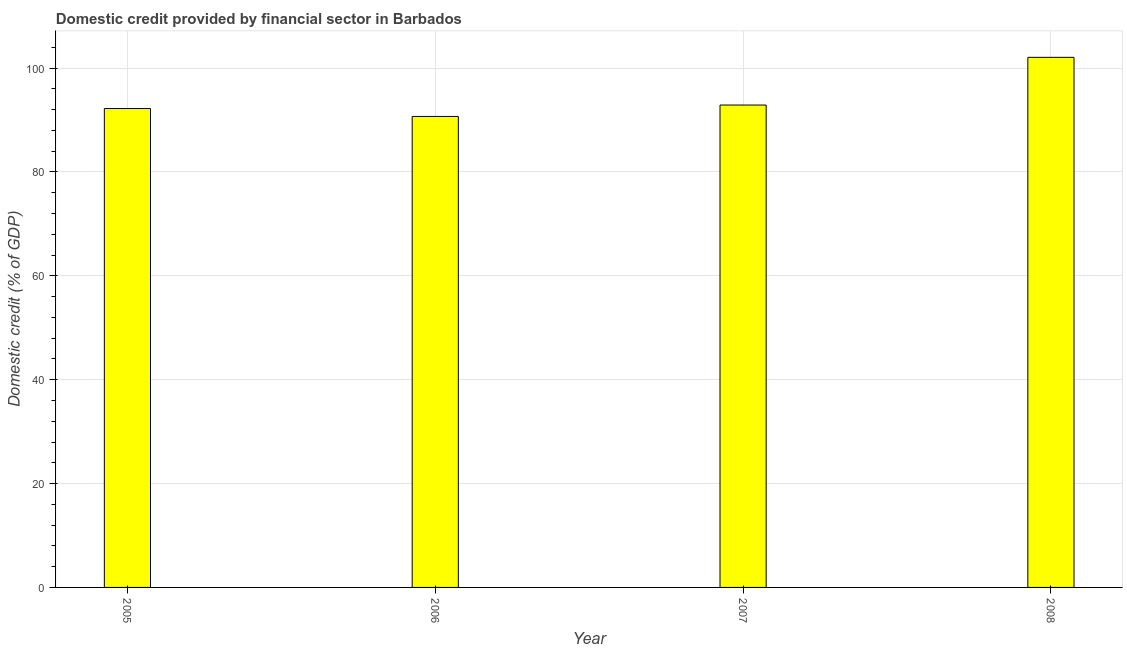Does the graph contain grids?
Provide a short and direct response. Yes. What is the title of the graph?
Offer a very short reply. Domestic credit provided by financial sector in Barbados. What is the label or title of the X-axis?
Your answer should be very brief. Year. What is the label or title of the Y-axis?
Keep it short and to the point. Domestic credit (% of GDP). What is the domestic credit provided by financial sector in 2007?
Give a very brief answer. 92.89. Across all years, what is the maximum domestic credit provided by financial sector?
Provide a short and direct response. 102.07. Across all years, what is the minimum domestic credit provided by financial sector?
Your answer should be very brief. 90.69. In which year was the domestic credit provided by financial sector minimum?
Offer a terse response. 2006. What is the sum of the domestic credit provided by financial sector?
Provide a short and direct response. 377.86. What is the difference between the domestic credit provided by financial sector in 2005 and 2008?
Offer a terse response. -9.86. What is the average domestic credit provided by financial sector per year?
Your answer should be very brief. 94.47. What is the median domestic credit provided by financial sector?
Your answer should be compact. 92.55. In how many years, is the domestic credit provided by financial sector greater than 48 %?
Provide a succinct answer. 4. What is the ratio of the domestic credit provided by financial sector in 2007 to that in 2008?
Keep it short and to the point. 0.91. What is the difference between the highest and the second highest domestic credit provided by financial sector?
Keep it short and to the point. 9.19. Is the sum of the domestic credit provided by financial sector in 2006 and 2008 greater than the maximum domestic credit provided by financial sector across all years?
Offer a very short reply. Yes. What is the difference between the highest and the lowest domestic credit provided by financial sector?
Offer a very short reply. 11.38. Are all the bars in the graph horizontal?
Ensure brevity in your answer.  No. What is the difference between two consecutive major ticks on the Y-axis?
Provide a short and direct response. 20. Are the values on the major ticks of Y-axis written in scientific E-notation?
Provide a short and direct response. No. What is the Domestic credit (% of GDP) in 2005?
Offer a very short reply. 92.21. What is the Domestic credit (% of GDP) in 2006?
Make the answer very short. 90.69. What is the Domestic credit (% of GDP) in 2007?
Offer a very short reply. 92.89. What is the Domestic credit (% of GDP) of 2008?
Offer a very short reply. 102.07. What is the difference between the Domestic credit (% of GDP) in 2005 and 2006?
Provide a succinct answer. 1.52. What is the difference between the Domestic credit (% of GDP) in 2005 and 2007?
Your response must be concise. -0.68. What is the difference between the Domestic credit (% of GDP) in 2005 and 2008?
Your response must be concise. -9.86. What is the difference between the Domestic credit (% of GDP) in 2006 and 2007?
Provide a succinct answer. -2.2. What is the difference between the Domestic credit (% of GDP) in 2006 and 2008?
Your response must be concise. -11.38. What is the difference between the Domestic credit (% of GDP) in 2007 and 2008?
Offer a very short reply. -9.19. What is the ratio of the Domestic credit (% of GDP) in 2005 to that in 2008?
Ensure brevity in your answer.  0.9. What is the ratio of the Domestic credit (% of GDP) in 2006 to that in 2007?
Ensure brevity in your answer.  0.98. What is the ratio of the Domestic credit (% of GDP) in 2006 to that in 2008?
Your answer should be compact. 0.89. What is the ratio of the Domestic credit (% of GDP) in 2007 to that in 2008?
Your answer should be compact. 0.91. 